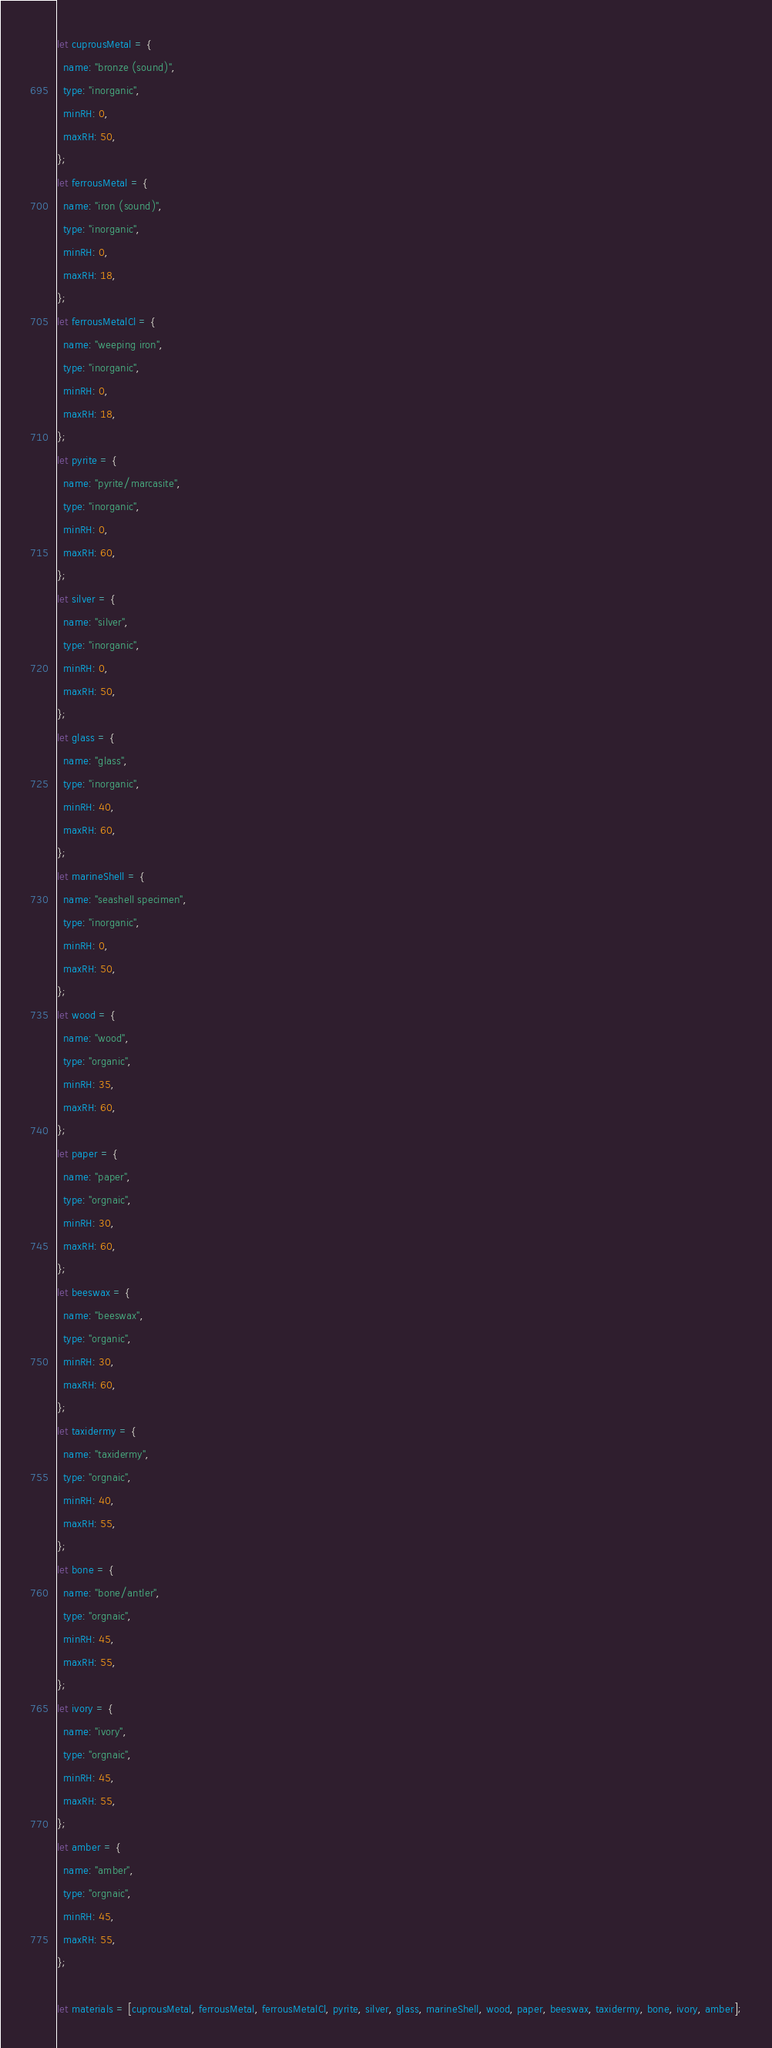<code> <loc_0><loc_0><loc_500><loc_500><_JavaScript_>let cuprousMetal = {
  name: "bronze (sound)",
  type: "inorganic",
  minRH: 0,
  maxRH: 50,
};
let ferrousMetal = {
  name: "iron (sound)",
  type: "inorganic",
  minRH: 0,
  maxRH: 18,
};
let ferrousMetalCl = {
  name: "weeping iron",
  type: "inorganic",
  minRH: 0,
  maxRH: 18,
};
let pyrite = {
  name: "pyrite/marcasite",
  type: "inorganic",
  minRH: 0,
  maxRH: 60,
};
let silver = {
  name: "silver",
  type: "inorganic",
  minRH: 0,
  maxRH: 50,
};
let glass = {
  name: "glass",
  type: "inorganic",
  minRH: 40,
  maxRH: 60,
};
let marineShell = {
  name: "seashell specimen",
  type: "inorganic",
  minRH: 0,
  maxRH: 50,
};
let wood = {
  name: "wood",
  type: "organic",
  minRH: 35,
  maxRH: 60,
};
let paper = {
  name: "paper",
  type: "orgnaic",
  minRH: 30,
  maxRH: 60,
};
let beeswax = {
  name: "beeswax",
  type: "organic",
  minRH: 30,
  maxRH: 60,
};
let taxidermy = {
  name: "taxidermy",
  type: "orgnaic",
  minRH: 40,
  maxRH: 55,
};
let bone = {
  name: "bone/antler",
  type: "orgnaic",
  minRH: 45,
  maxRH: 55,
};
let ivory = {
  name: "ivory",
  type: "orgnaic",
  minRH: 45,
  maxRH: 55,
};
let amber = {
  name: "amber",
  type: "orgnaic",
  minRH: 45,
  maxRH: 55,
};

let materials = [cuprousMetal, ferrousMetal, ferrousMetalCl, pyrite, silver, glass, marineShell, wood, paper, beeswax, taxidermy, bone, ivory, amber];
</code> 